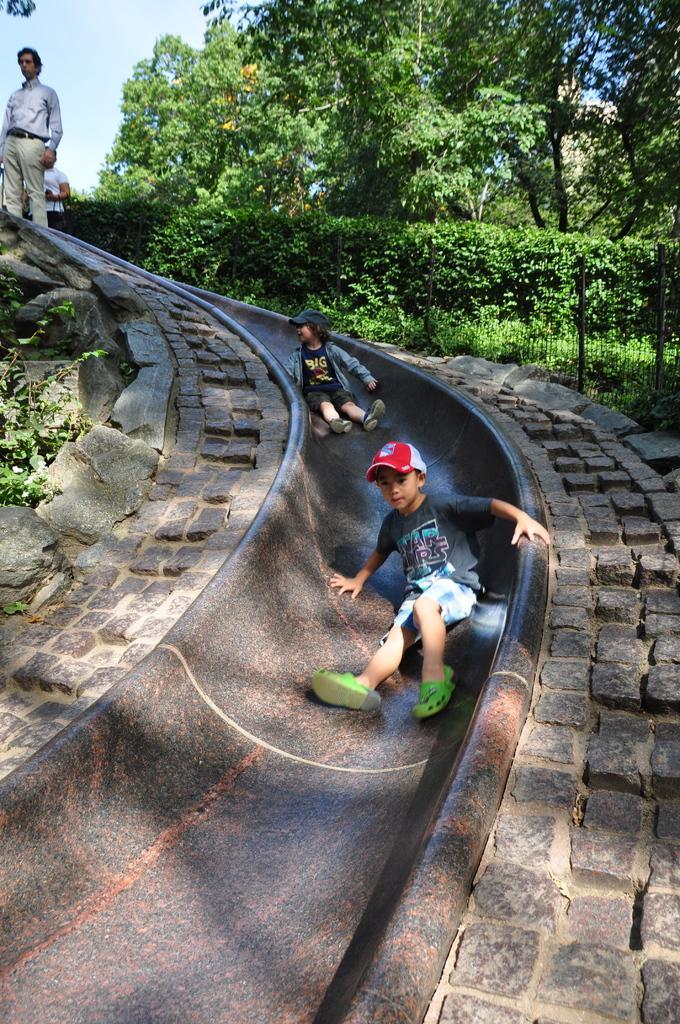In one or two sentences, can you explain what this image depicts? In this picture there are people, among them there are two kids sitting on a slide and we can see plants and trees. In the background of the image we can see the sky. 